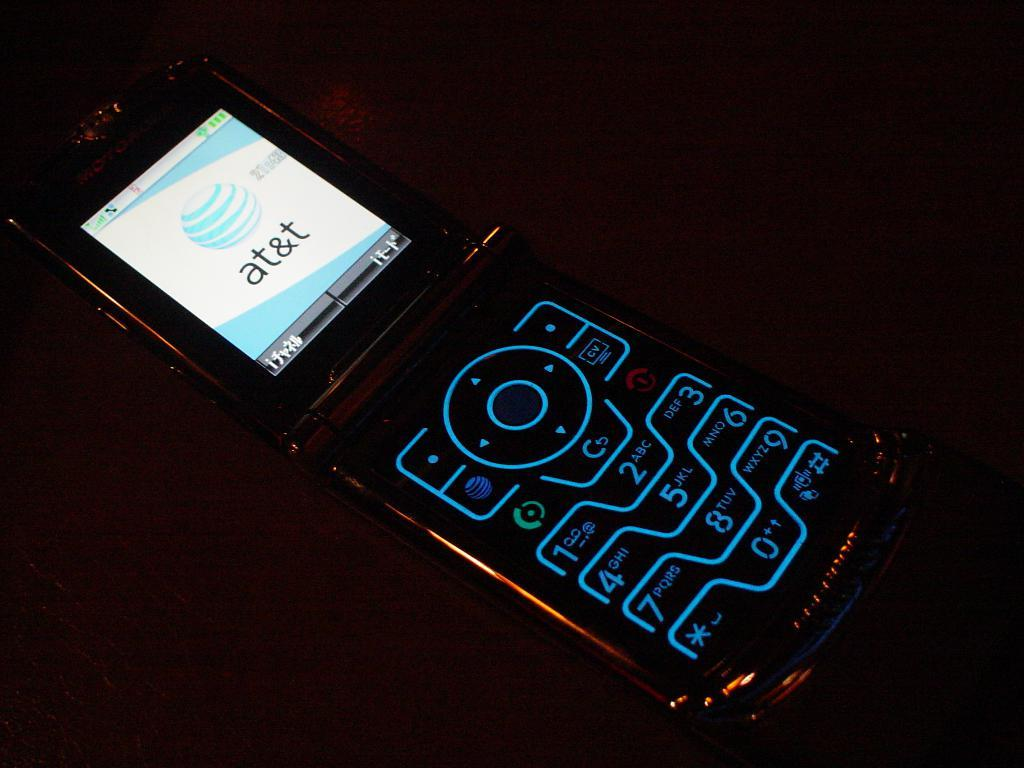<image>
Share a concise interpretation of the image provided. A cell phone is displaying the AT&T logo on its screen. 